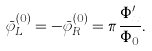<formula> <loc_0><loc_0><loc_500><loc_500>\bar { \varphi } _ { L } ^ { ( 0 ) } = - \bar { \varphi } _ { R } ^ { ( 0 ) } = \pi \frac { \Phi _ { x } ^ { \prime } } { \Phi _ { 0 } } .</formula> 